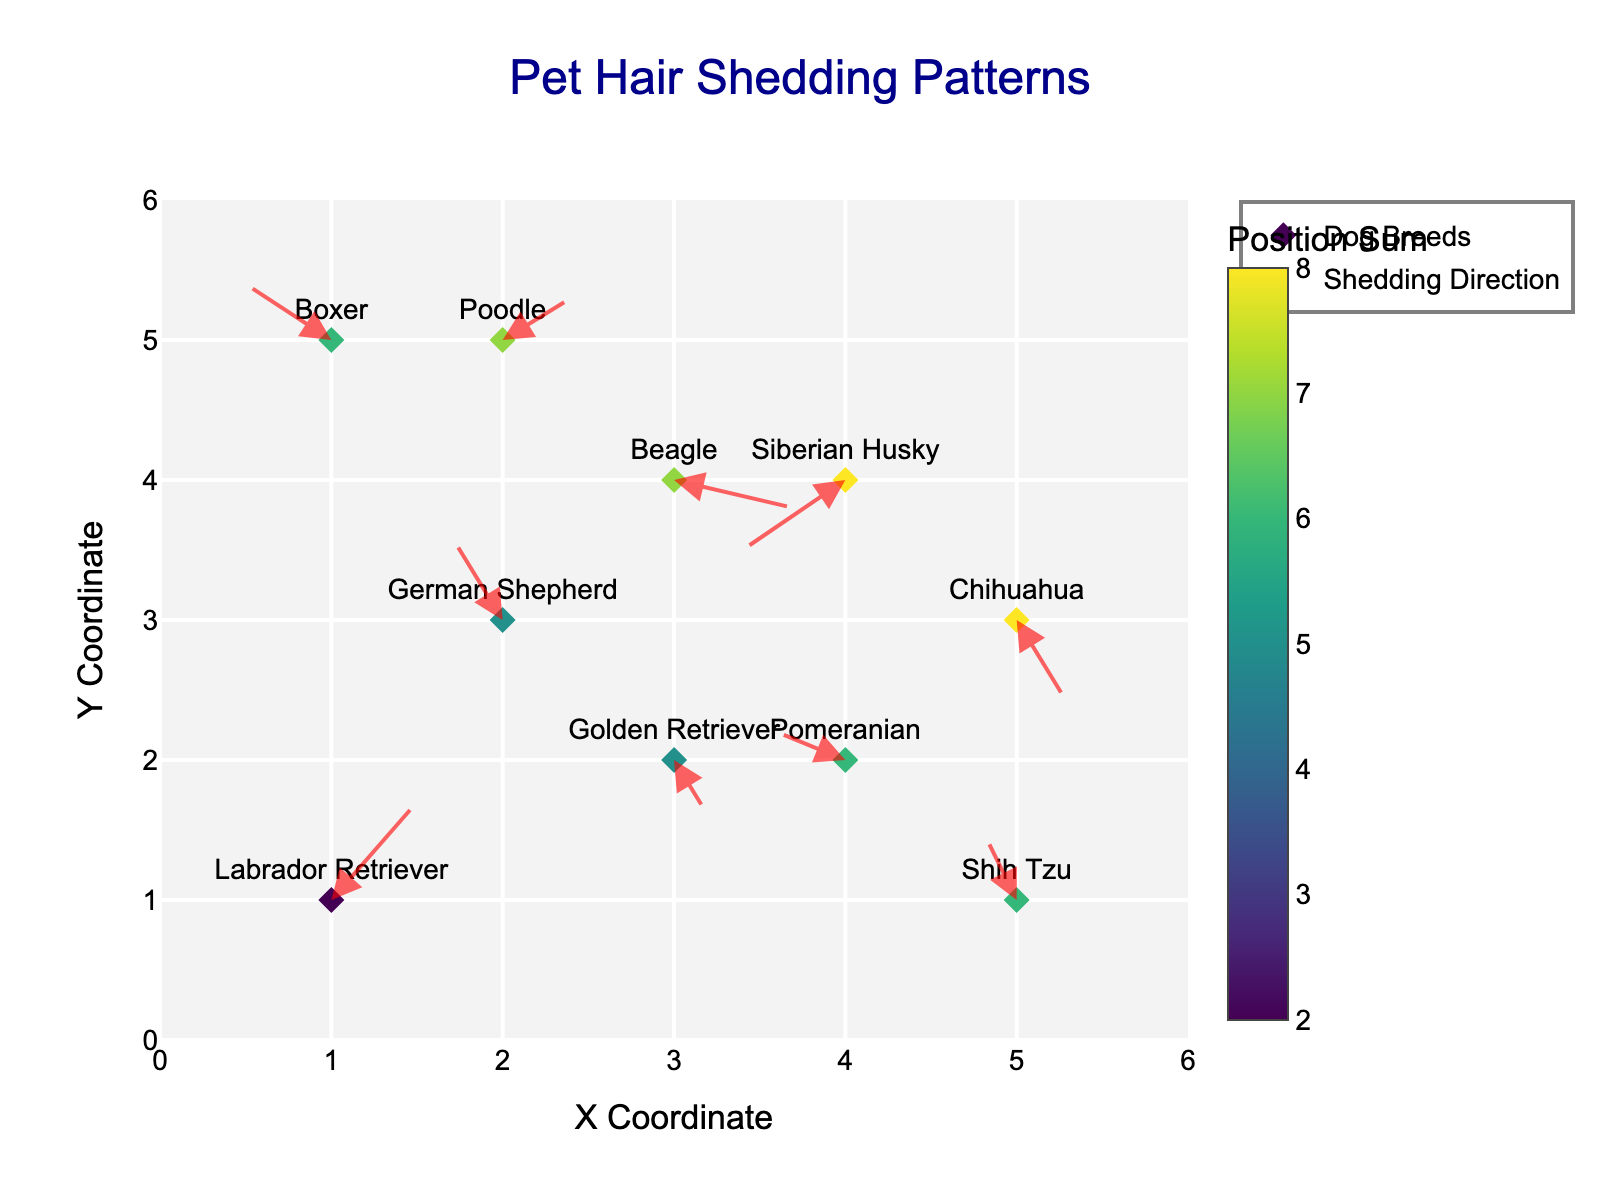What is the title of the plot? The title is usually mentioned at the top of the plot. In this case, it's clearly stated as "Pet Hair Shedding Patterns".
Answer: Pet Hair Shedding Patterns Which breed has an arrow pointing almost straight up? By inspecting the directions of the arrows, we can see that the arrows for the Labrador Retriever at (1,1) and German Shepherd at (2,3) are almost vertical but pointing slightly to different directions. The one closest to straight up is the German Shepherd's arrow.
Answer: German Shepherd How many dog breeds are there in the data? Look at the labels attached to the markers or the position count of the unique dogs. Each marker represents a different breed, counting them gives us 10.
Answer: 10 Which breed has the largest negative component in the shedding direction along the x-axis? Examine the components of the arrows along the x-axis (u). The Siberian Husky's arrow at (4,4) has the largest negative x-direction component (-0.6).
Answer: Siberian Husky What's the breed with the shedding direction mostly horizontal? A mostly horizontal direction means that the y-component (v) is very small or 0. The Golden Retriever's arrow at (3,2) has a significantly minor v component of -0.4 compared to its larger u component of 0.2.
Answer: Golden Retriever Are there any breeds with arrows that show shedding direction both upward and to the right? Look for arrows with positive u and v components, which indicates both an upward and rightward shedding direction. The Labrador Retriever (1, 1) has u = 0.5 and v = 0.7, and the Poodle (2,5) has u = 0.4 and v = 0.3.
Answer: Labrador Retriever, Poodle Which two breeds have arrows showing shedding directions in opposite quadrants? Opposite quadrants require finding two breeds where one’s direction is positive in x and y, while the other's is negative in both x and y or vice versa. The Labrador Retriever (1,1) with positive u and v (0.5 and 0.7) and the Siberian Husky (4,4) with negative u and v (-0.6 and -0.5) fit these criteria.
Answer: Labrador Retriever and Siberian Husky What is the direction of shedding for the Beagle and in which quadrant does it indicate movement? The Beagle (3,4) has an arrow with components u = 0.7 and v = -0.2, indicating the shedding direction is primarily right with slight downwards. This places the direction in the fourth quadrant (positive x, negative y).
Answer: Fourth quadrant Which breed is located the furthest in the positive x direction and where is its arrow pointing? The breed with the largest x-coordinate is the Shih Tzu (5,1). Its arrow points with u = -0.2 and v = 0.5 indicating the direction is toward the left and upward.
Answer: Shih Tzu and left-upward 